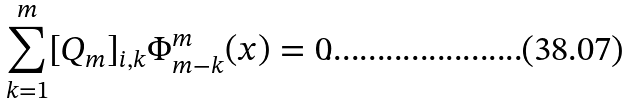Convert formula to latex. <formula><loc_0><loc_0><loc_500><loc_500>\sum _ { k = 1 } ^ { m } [ Q _ { m } ] _ { i , k } \Phi ^ { m } _ { m - k } ( x ) = 0</formula> 